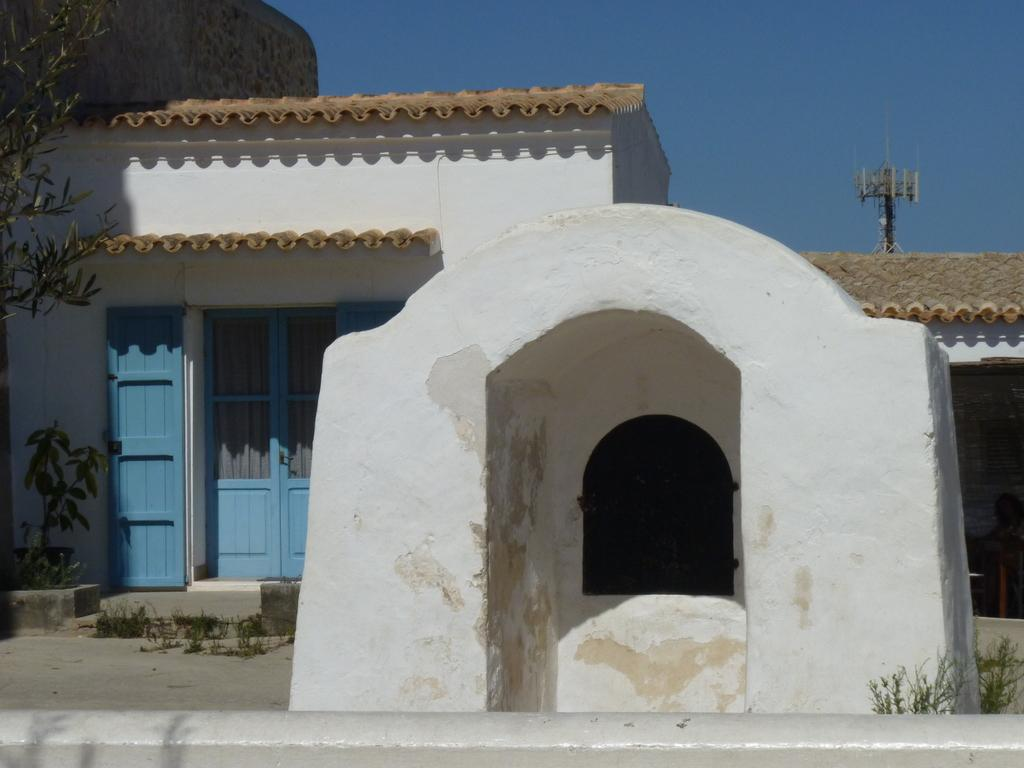What type of structure is present in the image? There is a building in the image. What is located in front of the building? There are plants in front of the building. What can be seen in the background of the image? There is a pole visible in the background, and the sky is clear. Is there a volcano erupting in the background of the image? No, there is no volcano present in the image. What type of brush is being used to clean the building in the image? There is no brush visible in the image, and the building does not appear to be undergoing any cleaning process. 